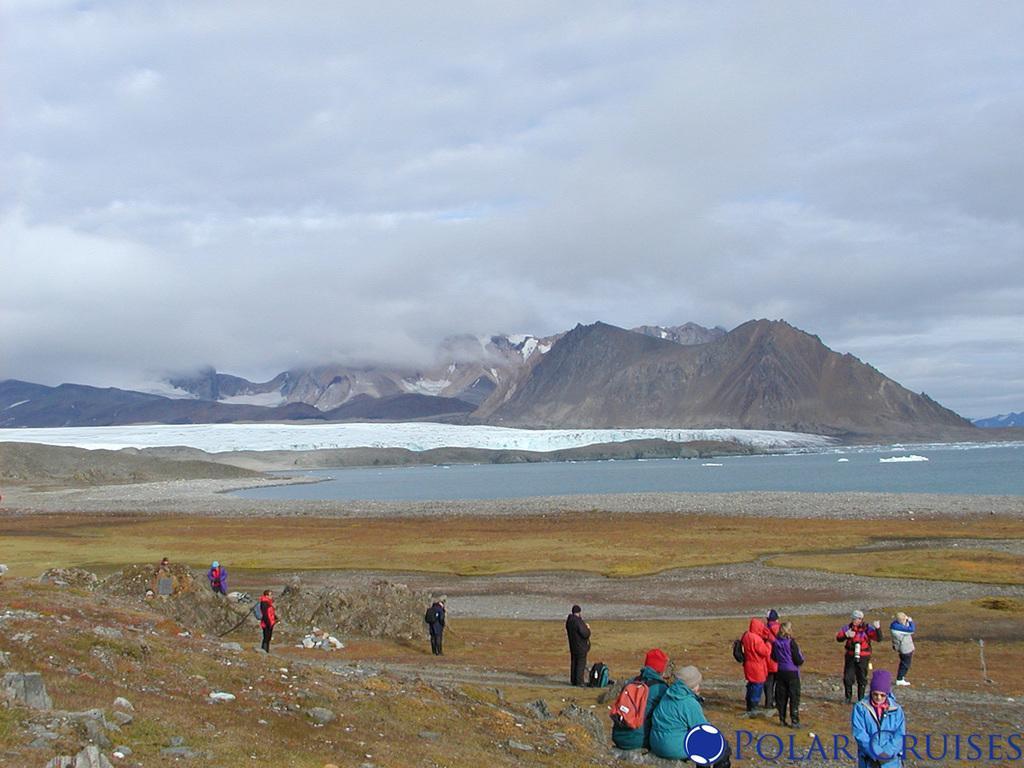Could you give a brief overview of what you see in this image? In this picture we can see some people on the ground. Behind the people, there are mountains and water. At the top of the image, there is the cloudy sky. In the bottom right corner of the image, there is a watermark. 